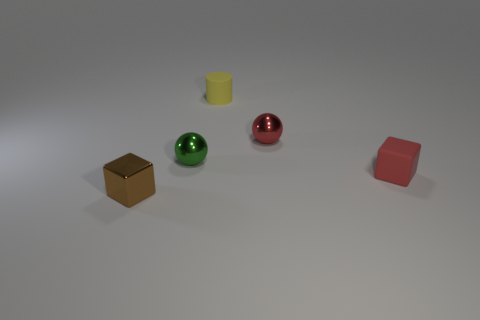Add 4 yellow rubber balls. How many objects exist? 9 Subtract all cubes. How many objects are left? 3 Add 5 green things. How many green things exist? 6 Subtract 1 green spheres. How many objects are left? 4 Subtract all purple matte spheres. Subtract all tiny green shiny things. How many objects are left? 4 Add 2 tiny metal cubes. How many tiny metal cubes are left? 3 